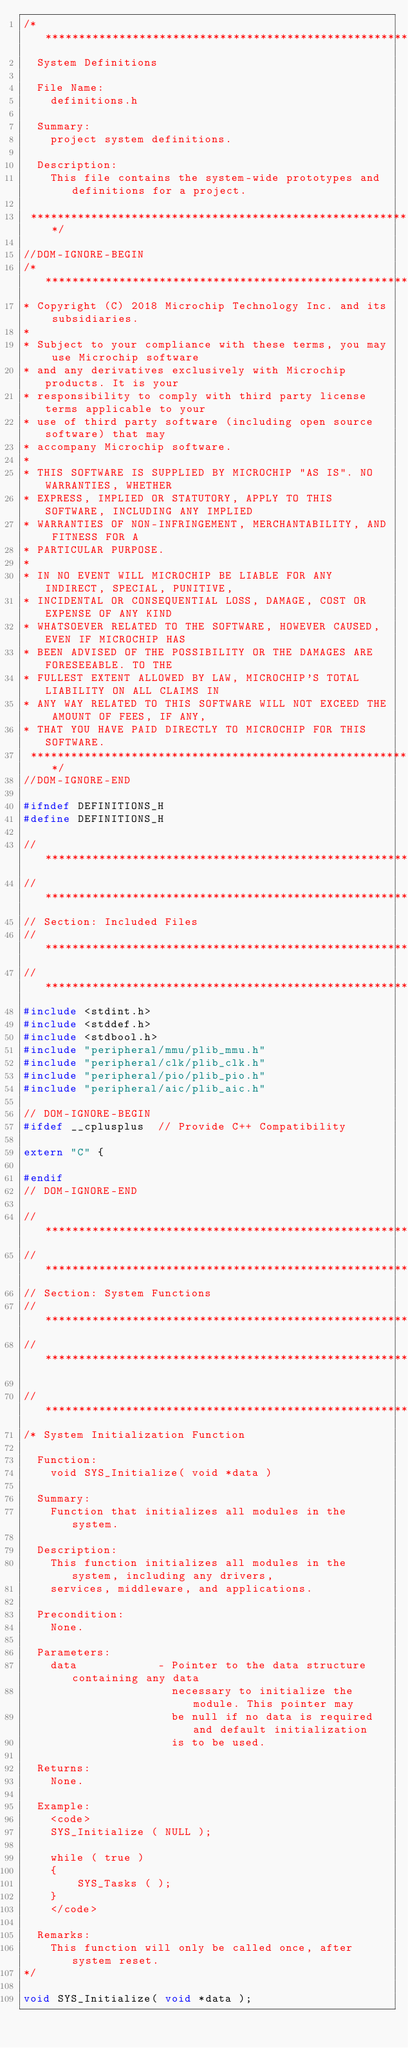<code> <loc_0><loc_0><loc_500><loc_500><_C_>/*******************************************************************************
  System Definitions

  File Name:
    definitions.h

  Summary:
    project system definitions.

  Description:
    This file contains the system-wide prototypes and definitions for a project.

 *******************************************************************************/

//DOM-IGNORE-BEGIN
/*******************************************************************************
* Copyright (C) 2018 Microchip Technology Inc. and its subsidiaries.
*
* Subject to your compliance with these terms, you may use Microchip software
* and any derivatives exclusively with Microchip products. It is your
* responsibility to comply with third party license terms applicable to your
* use of third party software (including open source software) that may
* accompany Microchip software.
*
* THIS SOFTWARE IS SUPPLIED BY MICROCHIP "AS IS". NO WARRANTIES, WHETHER
* EXPRESS, IMPLIED OR STATUTORY, APPLY TO THIS SOFTWARE, INCLUDING ANY IMPLIED
* WARRANTIES OF NON-INFRINGEMENT, MERCHANTABILITY, AND FITNESS FOR A
* PARTICULAR PURPOSE.
*
* IN NO EVENT WILL MICROCHIP BE LIABLE FOR ANY INDIRECT, SPECIAL, PUNITIVE,
* INCIDENTAL OR CONSEQUENTIAL LOSS, DAMAGE, COST OR EXPENSE OF ANY KIND
* WHATSOEVER RELATED TO THE SOFTWARE, HOWEVER CAUSED, EVEN IF MICROCHIP HAS
* BEEN ADVISED OF THE POSSIBILITY OR THE DAMAGES ARE FORESEEABLE. TO THE
* FULLEST EXTENT ALLOWED BY LAW, MICROCHIP'S TOTAL LIABILITY ON ALL CLAIMS IN
* ANY WAY RELATED TO THIS SOFTWARE WILL NOT EXCEED THE AMOUNT OF FEES, IF ANY,
* THAT YOU HAVE PAID DIRECTLY TO MICROCHIP FOR THIS SOFTWARE.
 *******************************************************************************/
//DOM-IGNORE-END

#ifndef DEFINITIONS_H
#define DEFINITIONS_H

// *****************************************************************************
// *****************************************************************************
// Section: Included Files
// *****************************************************************************
// *****************************************************************************
#include <stdint.h>
#include <stddef.h>
#include <stdbool.h>
#include "peripheral/mmu/plib_mmu.h"
#include "peripheral/clk/plib_clk.h"
#include "peripheral/pio/plib_pio.h"
#include "peripheral/aic/plib_aic.h"

// DOM-IGNORE-BEGIN
#ifdef __cplusplus  // Provide C++ Compatibility

extern "C" {

#endif
// DOM-IGNORE-END

// *****************************************************************************
// *****************************************************************************
// Section: System Functions
// *****************************************************************************
// *****************************************************************************

// *****************************************************************************
/* System Initialization Function

  Function:
    void SYS_Initialize( void *data )

  Summary:
    Function that initializes all modules in the system.

  Description:
    This function initializes all modules in the system, including any drivers,
    services, middleware, and applications.

  Precondition:
    None.

  Parameters:
    data            - Pointer to the data structure containing any data
                      necessary to initialize the module. This pointer may
                      be null if no data is required and default initialization
                      is to be used.

  Returns:
    None.

  Example:
    <code>
    SYS_Initialize ( NULL );

    while ( true )
    {
        SYS_Tasks ( );
    }
    </code>

  Remarks:
    This function will only be called once, after system reset.
*/

void SYS_Initialize( void *data );
</code> 